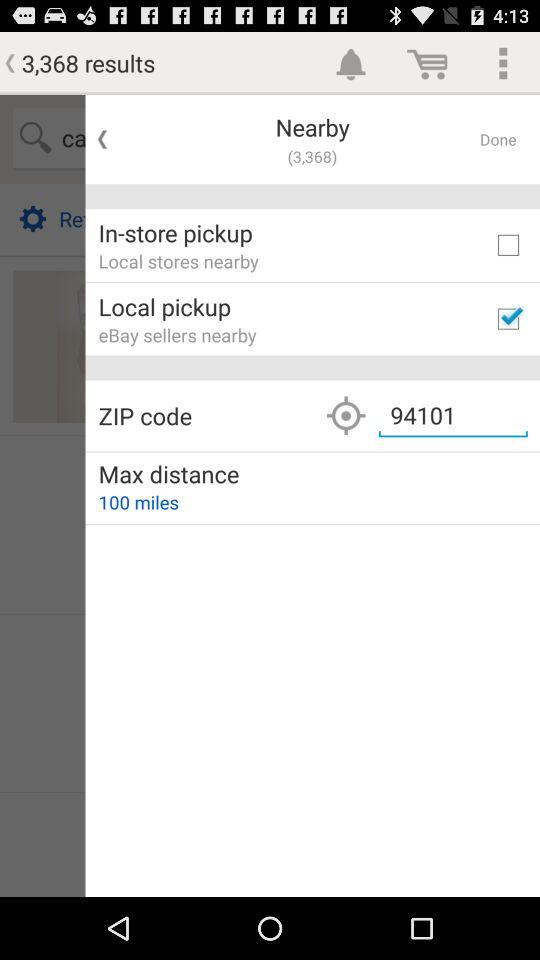What is the maximum distance? The maximum distance is 100 miles. 